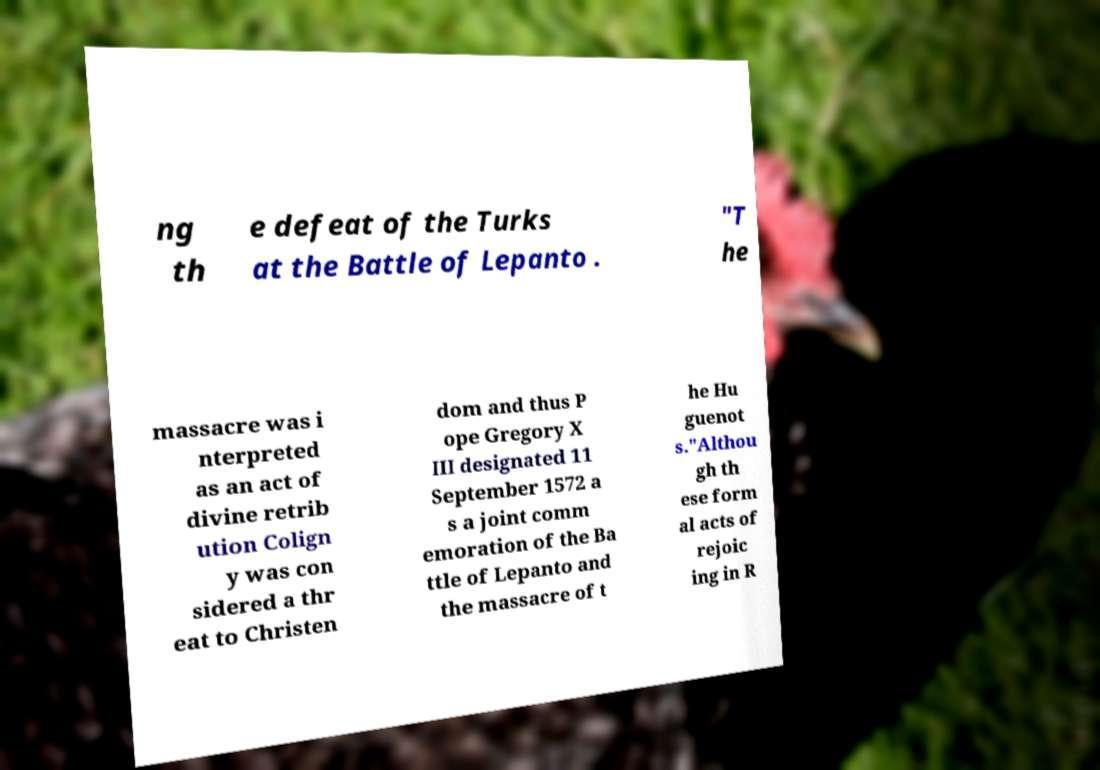There's text embedded in this image that I need extracted. Can you transcribe it verbatim? ng th e defeat of the Turks at the Battle of Lepanto . "T he massacre was i nterpreted as an act of divine retrib ution Colign y was con sidered a thr eat to Christen dom and thus P ope Gregory X III designated 11 September 1572 a s a joint comm emoration of the Ba ttle of Lepanto and the massacre of t he Hu guenot s."Althou gh th ese form al acts of rejoic ing in R 